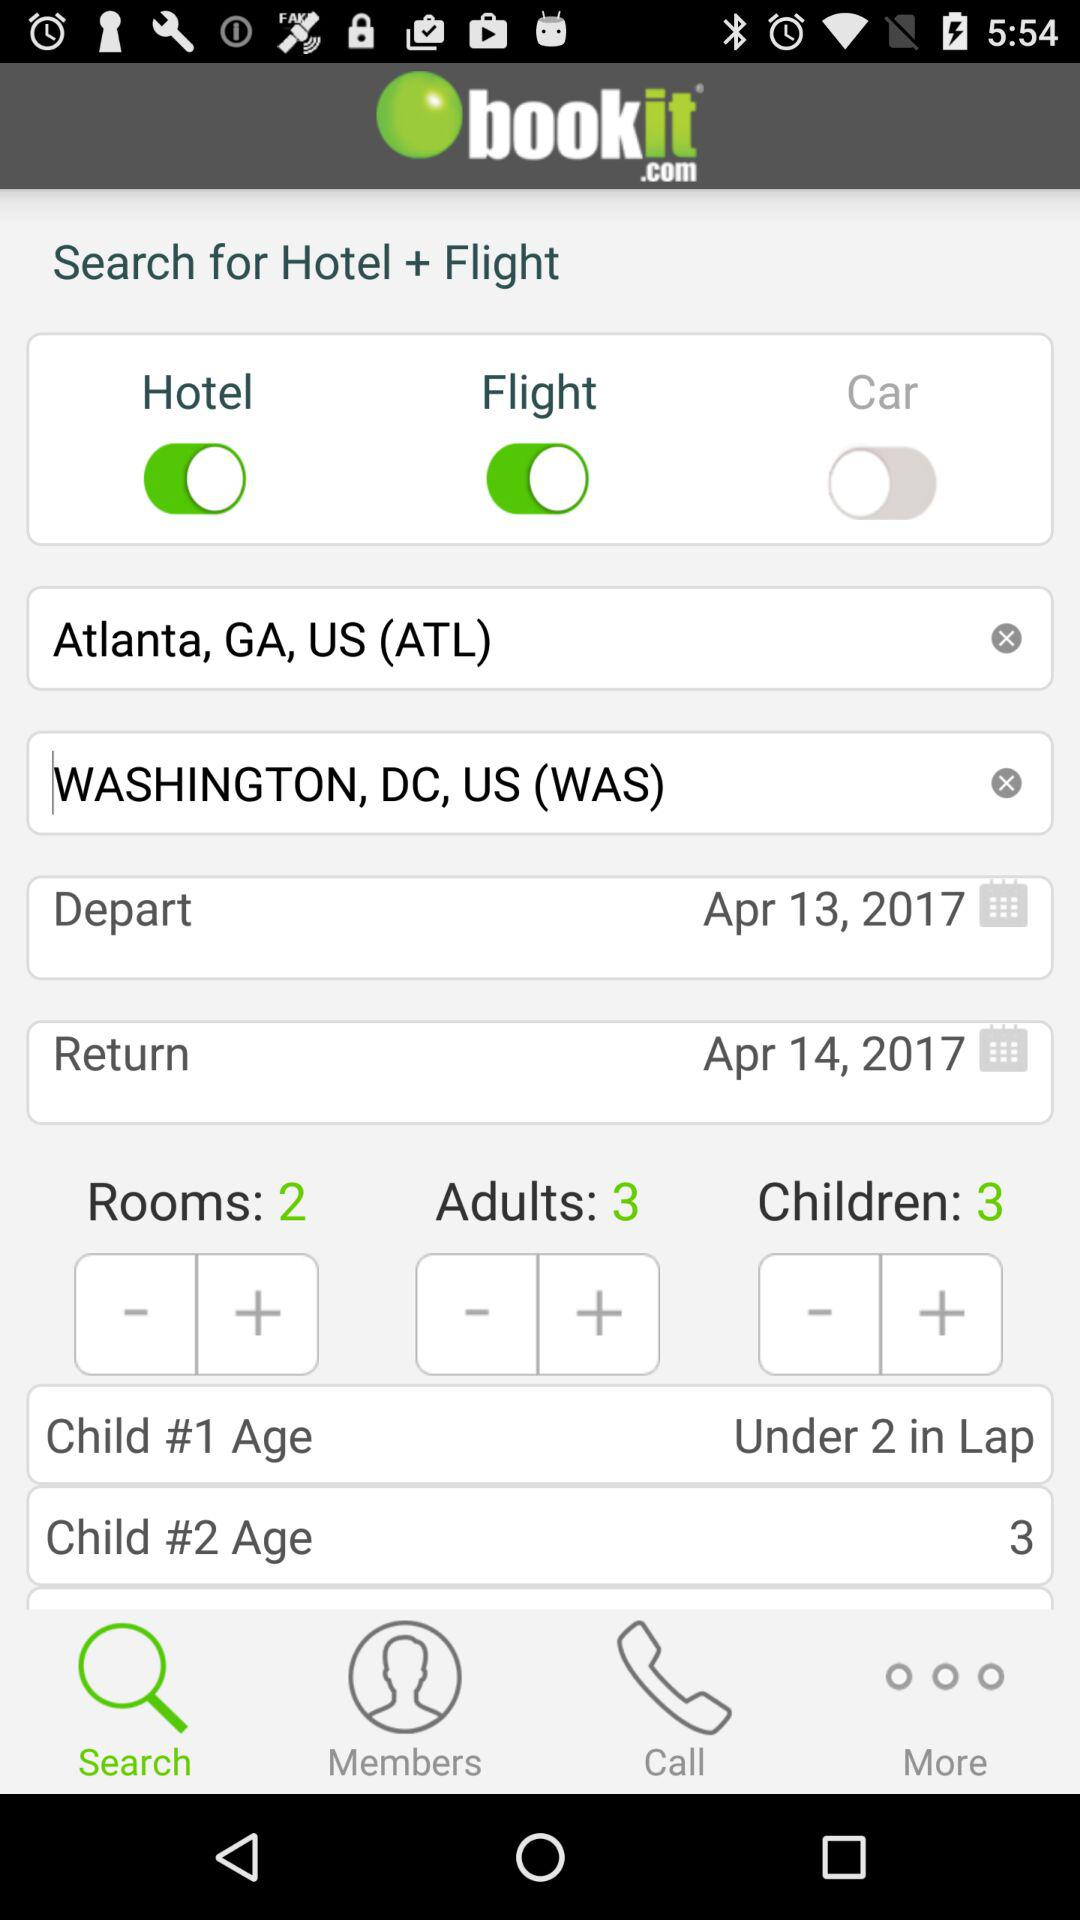Which tab is selected? The selected tab is "Search". 